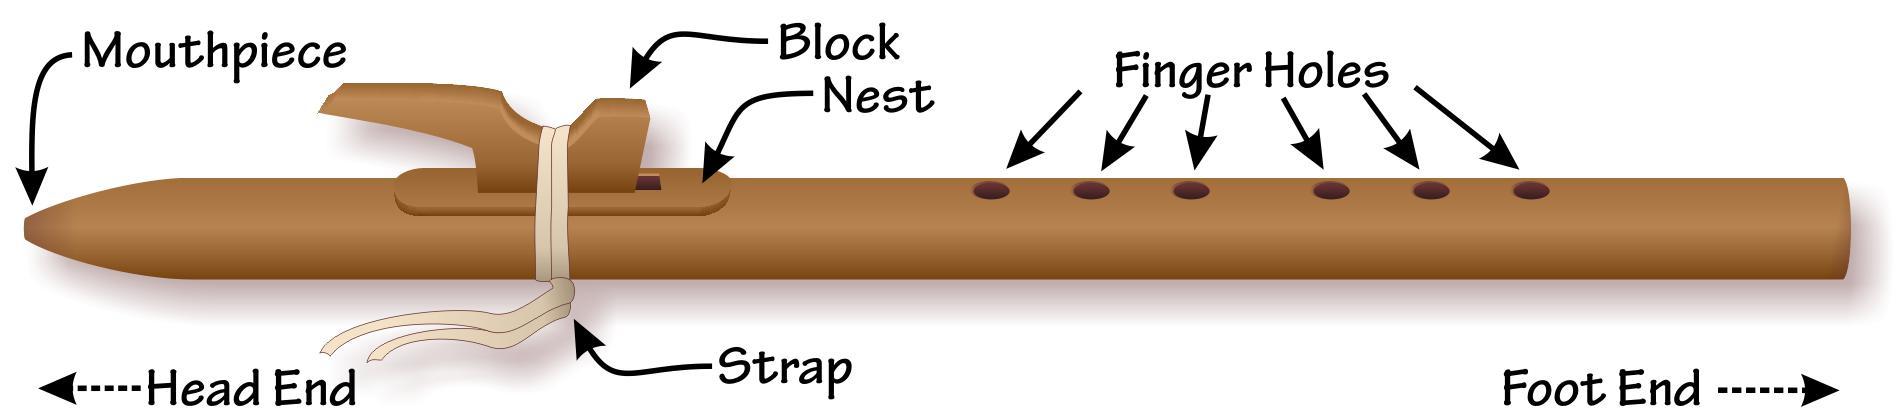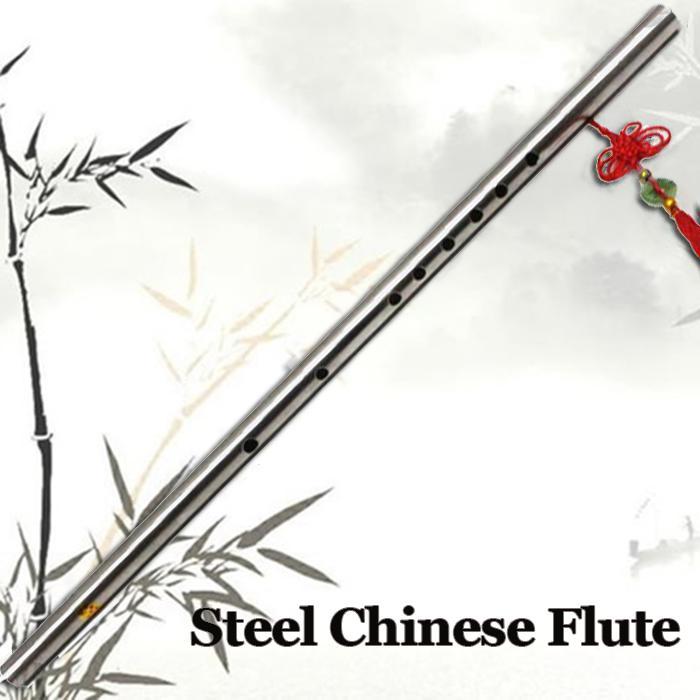The first image is the image on the left, the second image is the image on the right. For the images displayed, is the sentence "There are two flute illustrations in the right image." factually correct? Answer yes or no. No. The first image is the image on the left, the second image is the image on the right. Examine the images to the left and right. Is the description "The left and right image contains a total of three flutes." accurate? Answer yes or no. No. 